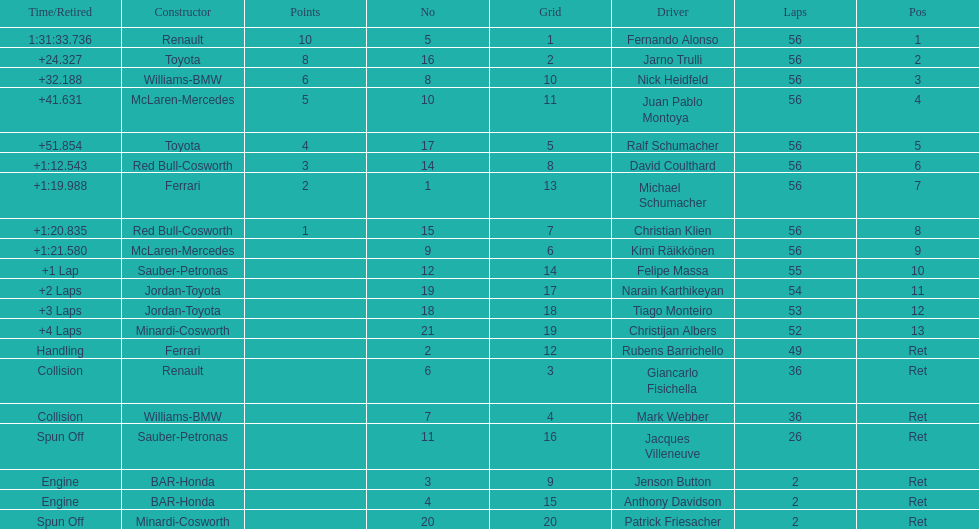How many bmws completed ahead of webber? 1. 